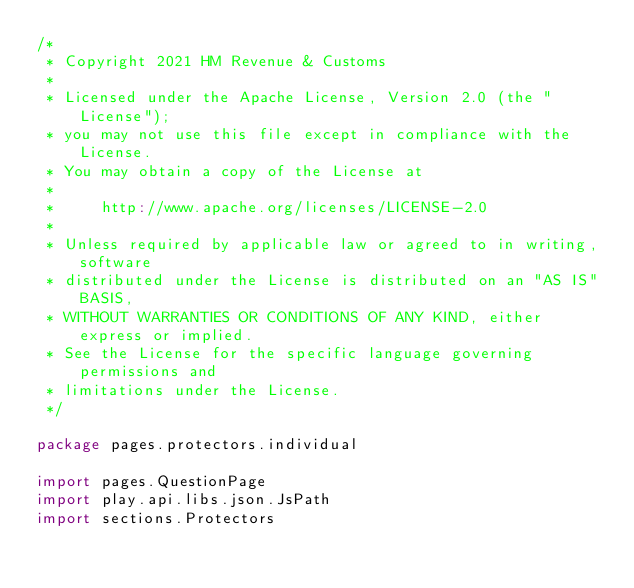<code> <loc_0><loc_0><loc_500><loc_500><_Scala_>/*
 * Copyright 2021 HM Revenue & Customs
 *
 * Licensed under the Apache License, Version 2.0 (the "License");
 * you may not use this file except in compliance with the License.
 * You may obtain a copy of the License at
 *
 *     http://www.apache.org/licenses/LICENSE-2.0
 *
 * Unless required by applicable law or agreed to in writing, software
 * distributed under the License is distributed on an "AS IS" BASIS,
 * WITHOUT WARRANTIES OR CONDITIONS OF ANY KIND, either express or implied.
 * See the License for the specific language governing permissions and
 * limitations under the License.
 */

package pages.protectors.individual

import pages.QuestionPage
import play.api.libs.json.JsPath
import sections.Protectors
</code> 